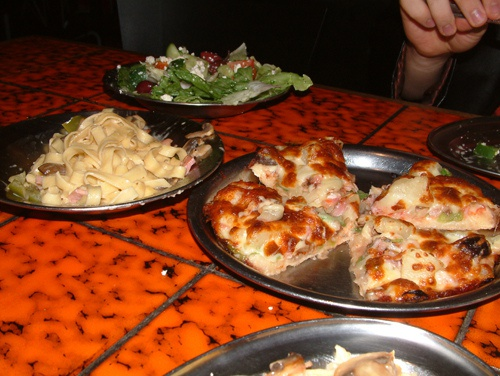Describe the objects in this image and their specific colors. I can see dining table in black, red, and maroon tones, pizza in black, tan, brown, and maroon tones, people in black, brown, and maroon tones, broccoli in black, darkgreen, and olive tones, and broccoli in black, darkgreen, and olive tones in this image. 